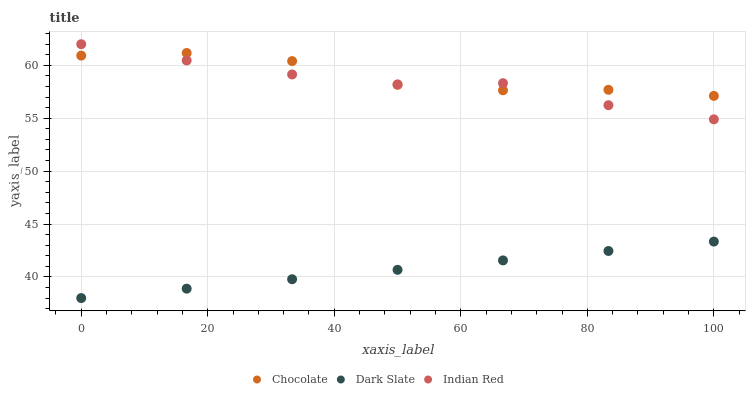Does Dark Slate have the minimum area under the curve?
Answer yes or no. Yes. Does Chocolate have the maximum area under the curve?
Answer yes or no. Yes. Does Indian Red have the minimum area under the curve?
Answer yes or no. No. Does Indian Red have the maximum area under the curve?
Answer yes or no. No. Is Dark Slate the smoothest?
Answer yes or no. Yes. Is Chocolate the roughest?
Answer yes or no. Yes. Is Indian Red the smoothest?
Answer yes or no. No. Is Indian Red the roughest?
Answer yes or no. No. Does Dark Slate have the lowest value?
Answer yes or no. Yes. Does Indian Red have the lowest value?
Answer yes or no. No. Does Indian Red have the highest value?
Answer yes or no. Yes. Does Chocolate have the highest value?
Answer yes or no. No. Is Dark Slate less than Chocolate?
Answer yes or no. Yes. Is Indian Red greater than Dark Slate?
Answer yes or no. Yes. Does Chocolate intersect Indian Red?
Answer yes or no. Yes. Is Chocolate less than Indian Red?
Answer yes or no. No. Is Chocolate greater than Indian Red?
Answer yes or no. No. Does Dark Slate intersect Chocolate?
Answer yes or no. No. 